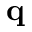<formula> <loc_0><loc_0><loc_500><loc_500>q</formula> 